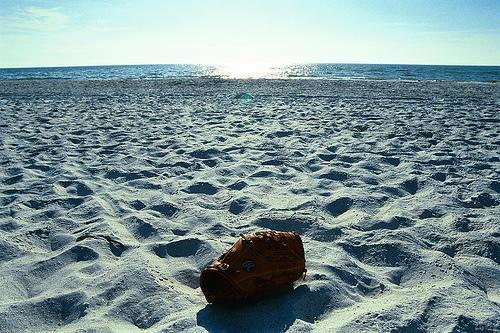How many gloves is on the beach?
Give a very brief answer. 1. 